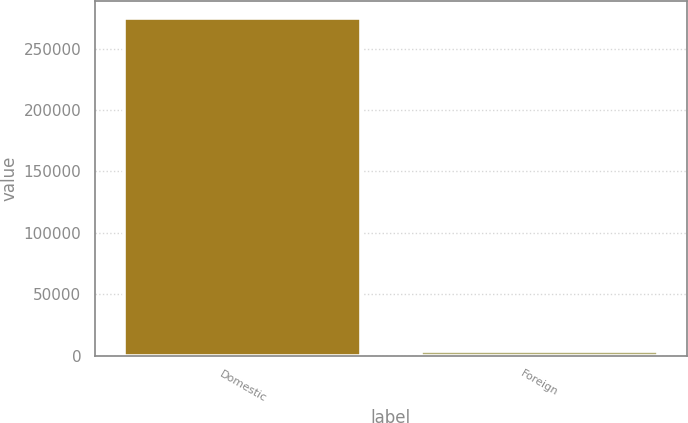Convert chart. <chart><loc_0><loc_0><loc_500><loc_500><bar_chart><fcel>Domestic<fcel>Foreign<nl><fcel>275091<fcel>4050<nl></chart> 